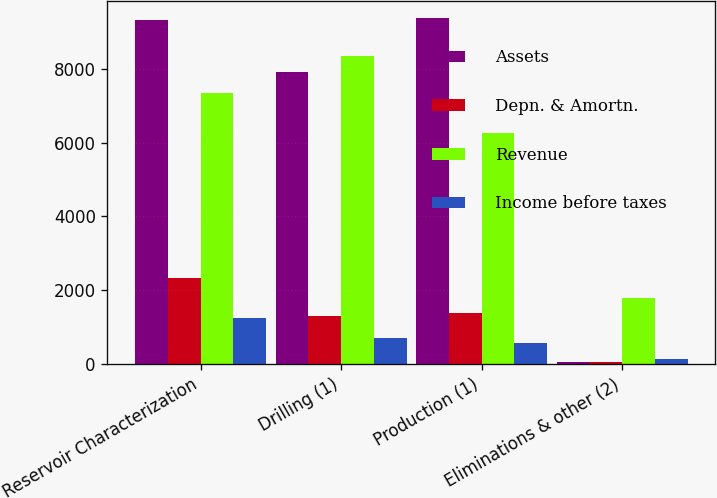<chart> <loc_0><loc_0><loc_500><loc_500><stacked_bar_chart><ecel><fcel>Reservoir Characterization<fcel>Drilling (1)<fcel>Production (1)<fcel>Eliminations & other (2)<nl><fcel>Assets<fcel>9321<fcel>7917<fcel>9366<fcel>68<nl><fcel>Depn. & Amortn.<fcel>2321<fcel>1313<fcel>1389<fcel>48<nl><fcel>Revenue<fcel>7338<fcel>8355<fcel>6254<fcel>1801<nl><fcel>Income before taxes<fcel>1246<fcel>721<fcel>571<fcel>142<nl></chart> 